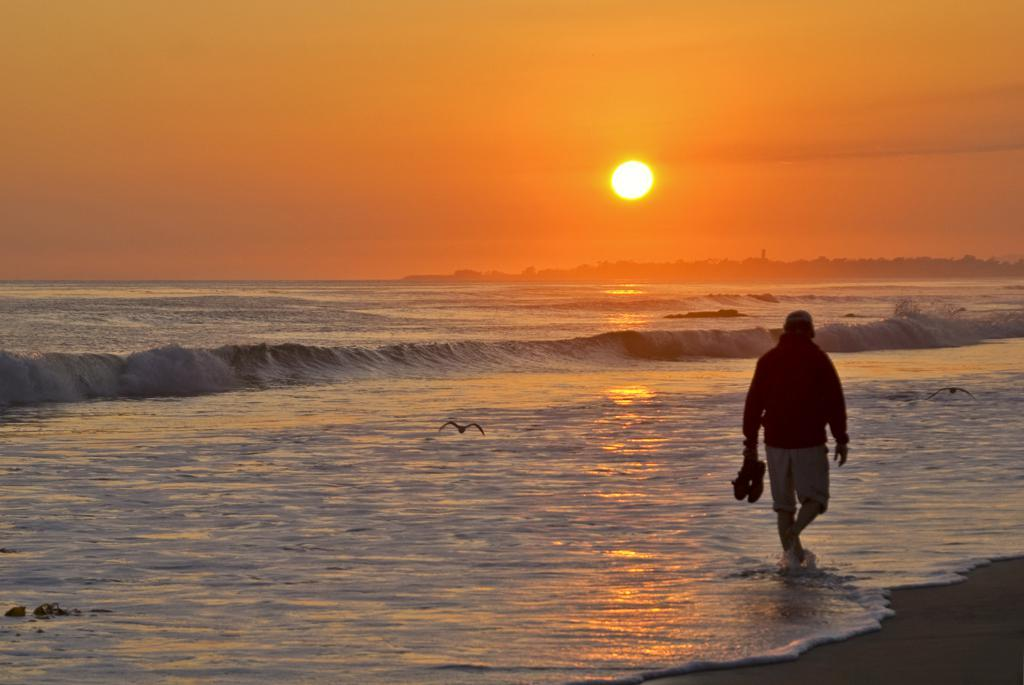What is the person in the image doing? The person is walking in the water. What is the person holding while walking in the water? The person is holding shoes. What type of animals can be seen in the image? There are birds in the image. What can be seen in the background of the image? There are trees, mountains, the sun, and the sky visible in the background of the image. What type of cakes are being served at the news conference in the image? There is no news conference or cakes present in the image; it features a person walking in the water while holding shoes. Can you tell me how many chess pieces are visible on the table in the image? There is no table or chess pieces present in the image. 